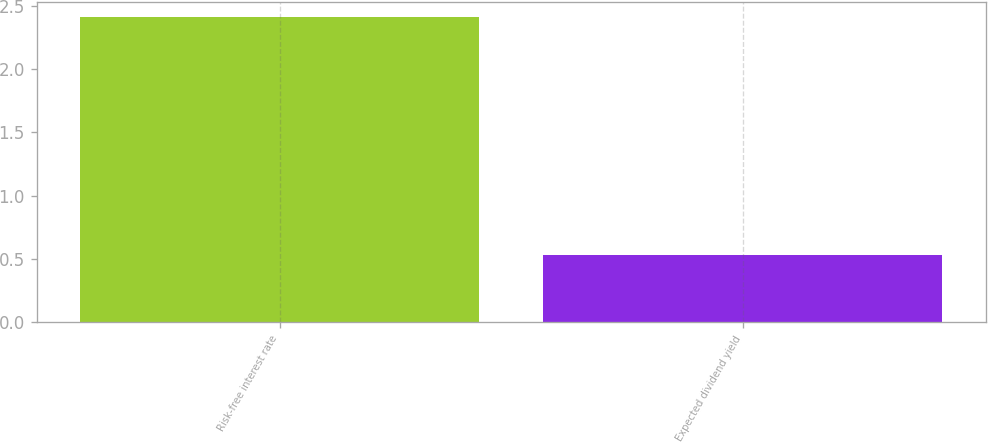Convert chart to OTSL. <chart><loc_0><loc_0><loc_500><loc_500><bar_chart><fcel>Risk-free interest rate<fcel>Expected dividend yield<nl><fcel>2.41<fcel>0.53<nl></chart> 